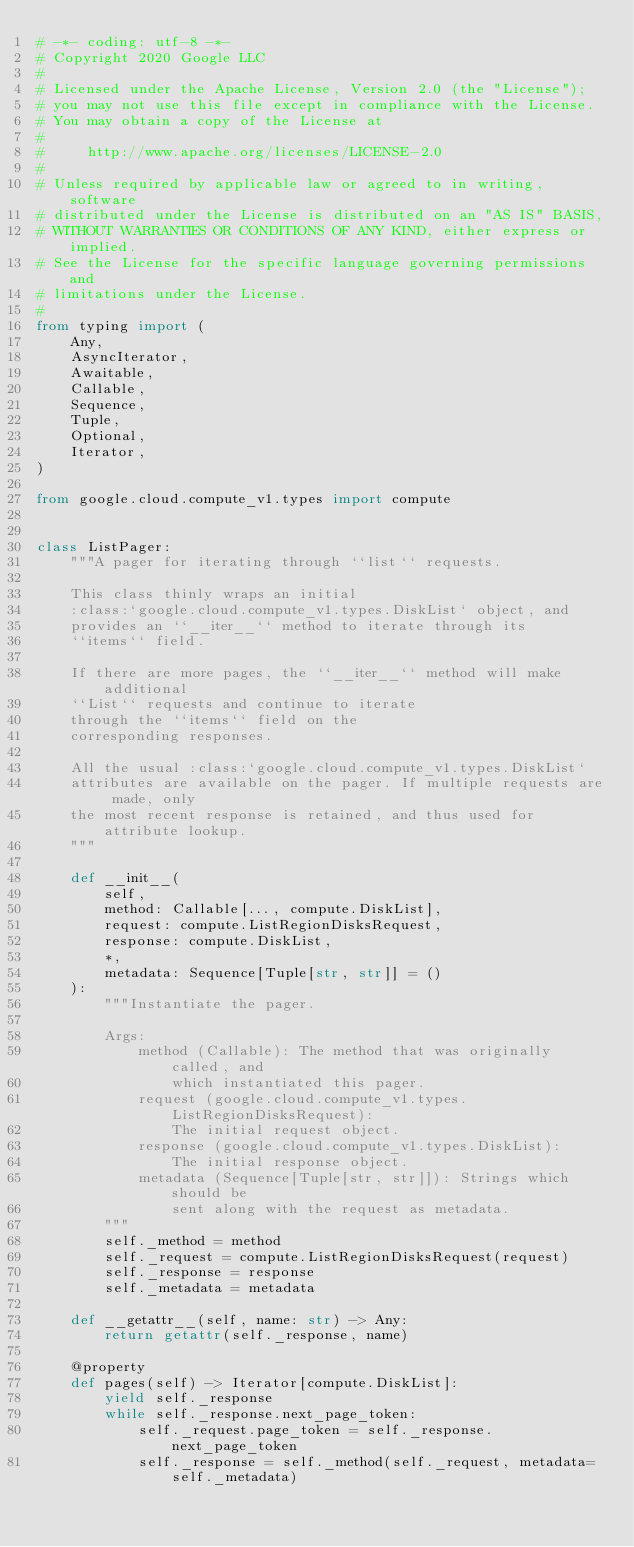<code> <loc_0><loc_0><loc_500><loc_500><_Python_># -*- coding: utf-8 -*-
# Copyright 2020 Google LLC
#
# Licensed under the Apache License, Version 2.0 (the "License");
# you may not use this file except in compliance with the License.
# You may obtain a copy of the License at
#
#     http://www.apache.org/licenses/LICENSE-2.0
#
# Unless required by applicable law or agreed to in writing, software
# distributed under the License is distributed on an "AS IS" BASIS,
# WITHOUT WARRANTIES OR CONDITIONS OF ANY KIND, either express or implied.
# See the License for the specific language governing permissions and
# limitations under the License.
#
from typing import (
    Any,
    AsyncIterator,
    Awaitable,
    Callable,
    Sequence,
    Tuple,
    Optional,
    Iterator,
)

from google.cloud.compute_v1.types import compute


class ListPager:
    """A pager for iterating through ``list`` requests.

    This class thinly wraps an initial
    :class:`google.cloud.compute_v1.types.DiskList` object, and
    provides an ``__iter__`` method to iterate through its
    ``items`` field.

    If there are more pages, the ``__iter__`` method will make additional
    ``List`` requests and continue to iterate
    through the ``items`` field on the
    corresponding responses.

    All the usual :class:`google.cloud.compute_v1.types.DiskList`
    attributes are available on the pager. If multiple requests are made, only
    the most recent response is retained, and thus used for attribute lookup.
    """

    def __init__(
        self,
        method: Callable[..., compute.DiskList],
        request: compute.ListRegionDisksRequest,
        response: compute.DiskList,
        *,
        metadata: Sequence[Tuple[str, str]] = ()
    ):
        """Instantiate the pager.

        Args:
            method (Callable): The method that was originally called, and
                which instantiated this pager.
            request (google.cloud.compute_v1.types.ListRegionDisksRequest):
                The initial request object.
            response (google.cloud.compute_v1.types.DiskList):
                The initial response object.
            metadata (Sequence[Tuple[str, str]]): Strings which should be
                sent along with the request as metadata.
        """
        self._method = method
        self._request = compute.ListRegionDisksRequest(request)
        self._response = response
        self._metadata = metadata

    def __getattr__(self, name: str) -> Any:
        return getattr(self._response, name)

    @property
    def pages(self) -> Iterator[compute.DiskList]:
        yield self._response
        while self._response.next_page_token:
            self._request.page_token = self._response.next_page_token
            self._response = self._method(self._request, metadata=self._metadata)</code> 